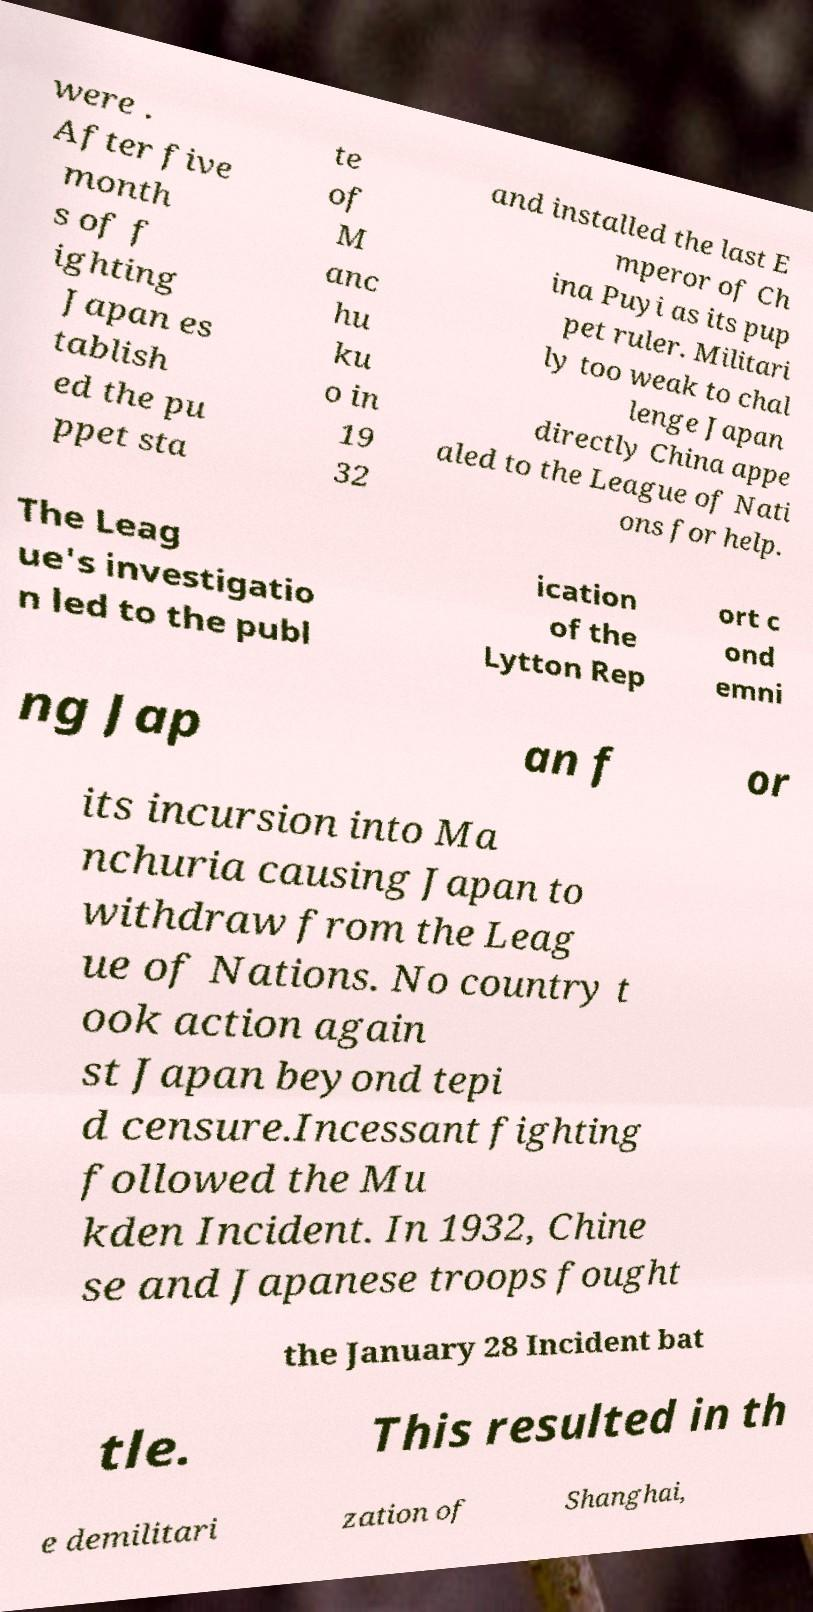Can you read and provide the text displayed in the image?This photo seems to have some interesting text. Can you extract and type it out for me? were . After five month s of f ighting Japan es tablish ed the pu ppet sta te of M anc hu ku o in 19 32 and installed the last E mperor of Ch ina Puyi as its pup pet ruler. Militari ly too weak to chal lenge Japan directly China appe aled to the League of Nati ons for help. The Leag ue's investigatio n led to the publ ication of the Lytton Rep ort c ond emni ng Jap an f or its incursion into Ma nchuria causing Japan to withdraw from the Leag ue of Nations. No country t ook action again st Japan beyond tepi d censure.Incessant fighting followed the Mu kden Incident. In 1932, Chine se and Japanese troops fought the January 28 Incident bat tle. This resulted in th e demilitari zation of Shanghai, 